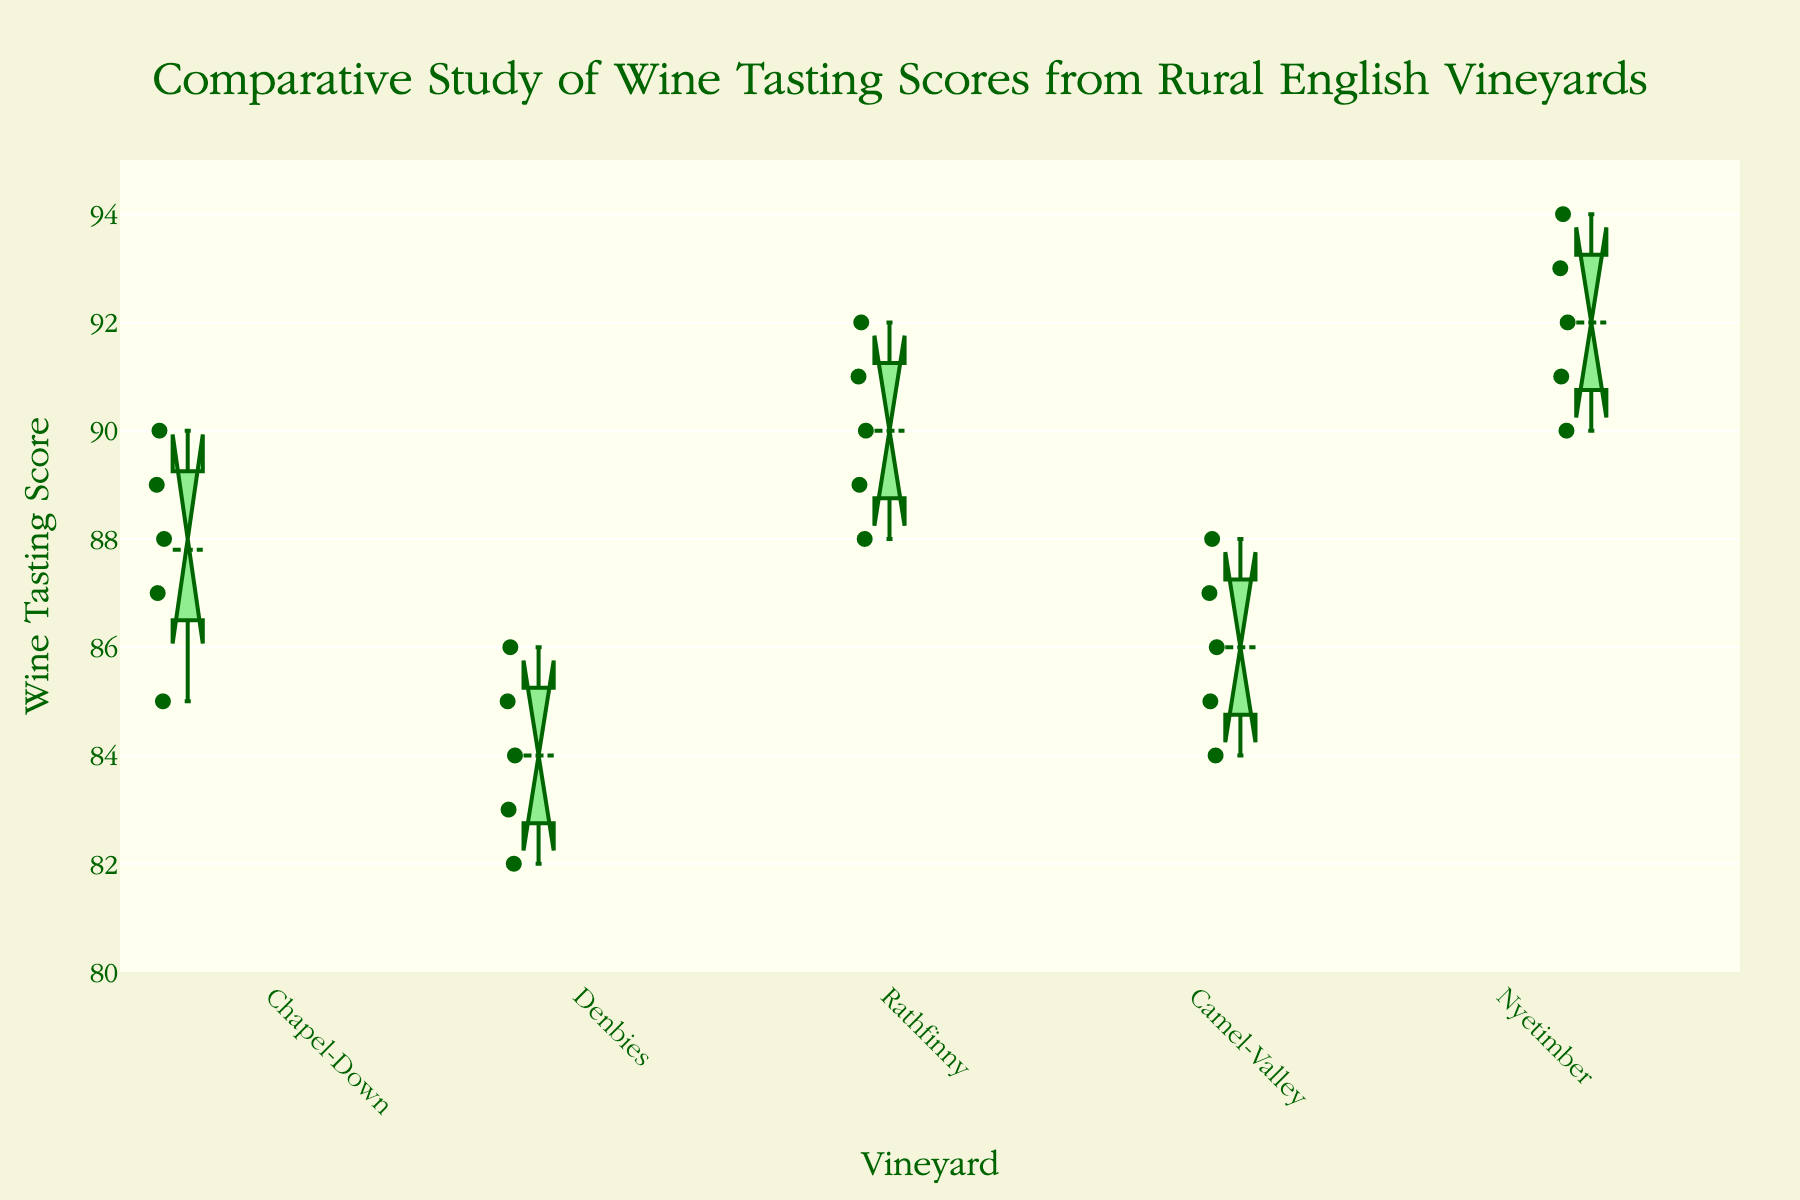What's the title of the figure? The title is located at the top of the plot. It reads "Comparative Study of Wine Tasting Scores from Rural English Vineyards".
Answer: Comparative Study of Wine Tasting Scores from Rural English Vineyards How many vineyards are compared in the figure? By counting the number of different box plots (each representing a vineyard), we can see that there are five vineyards compared.
Answer: Five What is the range of wine tasting scores shown on the y-axis? The range is observed on the y-axis, with the scale marking scores from 80 to 95.
Answer: 80 to 95 Which vineyard has the highest median wine tasting score? The median of each vineyard can be seen as the middle line in the box plot. The vineyard with the highest median line is Nyetimber.
Answer: Nyetimber Comparing Chapel-Down and Denbies, which vineyard shows a greater spread of wine tasting scores? The spread of scores can be viewed by the length of the box and whiskers. Chapel-Down appears to have a greater spread compared to Denbies.
Answer: Chapel-Down Which vineyard has the smallest variance in wine tasting scores? The vineyard with the smallest variance will have the shortest overall box and whiskers. Camel-Valley shows the smallest variance.
Answer: Camel-Valley Are there any vineyards where the notches of their box plots do not overlap? Non-overlapping notches indicate that there is a significant difference between the medians. Nyetimber and Denbies do not have overlapping notches.
Answer: Yes, Nyetimber and Denbies What can be said about outliers in any of the vineyard scores? Outliers are represented by individual points outside the whiskers. No outliers are present in any vineyard's data.
Answer: No outliers What is the interquartile range (IQR) for Rathfinny? The IQR is the difference between the first and third quartiles in the box plot. For Rathfinny, the box spans from around 88 to 91, giving an IQR of 3.
Answer: 3 Which vineyard, if any, has the lowest minimum score in its data set? The lowest minimum score is identified by looking at the bottom whiskers. Denbies has the lowest minimum score.
Answer: Denbies 